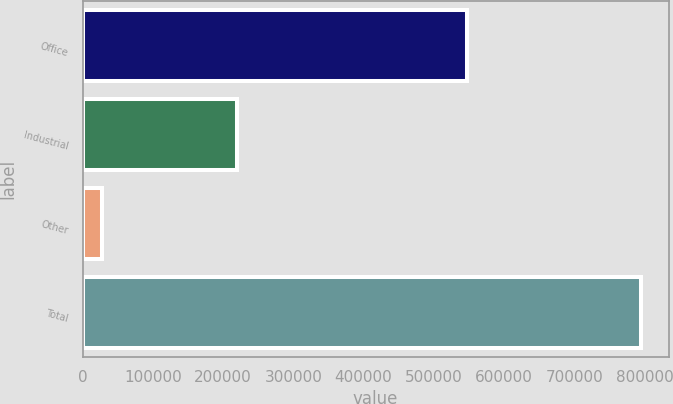Convert chart to OTSL. <chart><loc_0><loc_0><loc_500><loc_500><bar_chart><fcel>Office<fcel>Industrial<fcel>Other<fcel>Total<nl><fcel>547478<fcel>219080<fcel>27930<fcel>794488<nl></chart> 